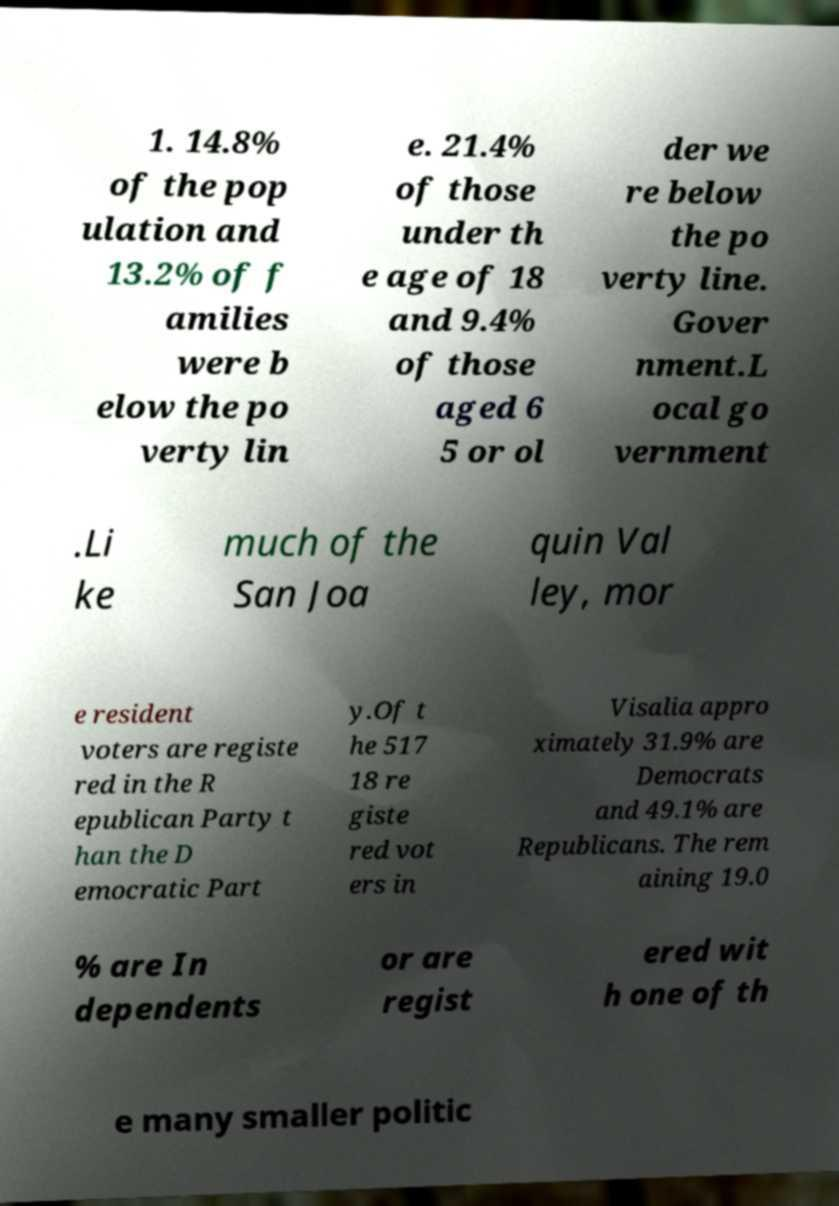For documentation purposes, I need the text within this image transcribed. Could you provide that? 1. 14.8% of the pop ulation and 13.2% of f amilies were b elow the po verty lin e. 21.4% of those under th e age of 18 and 9.4% of those aged 6 5 or ol der we re below the po verty line. Gover nment.L ocal go vernment .Li ke much of the San Joa quin Val ley, mor e resident voters are registe red in the R epublican Party t han the D emocratic Part y.Of t he 517 18 re giste red vot ers in Visalia appro ximately 31.9% are Democrats and 49.1% are Republicans. The rem aining 19.0 % are In dependents or are regist ered wit h one of th e many smaller politic 